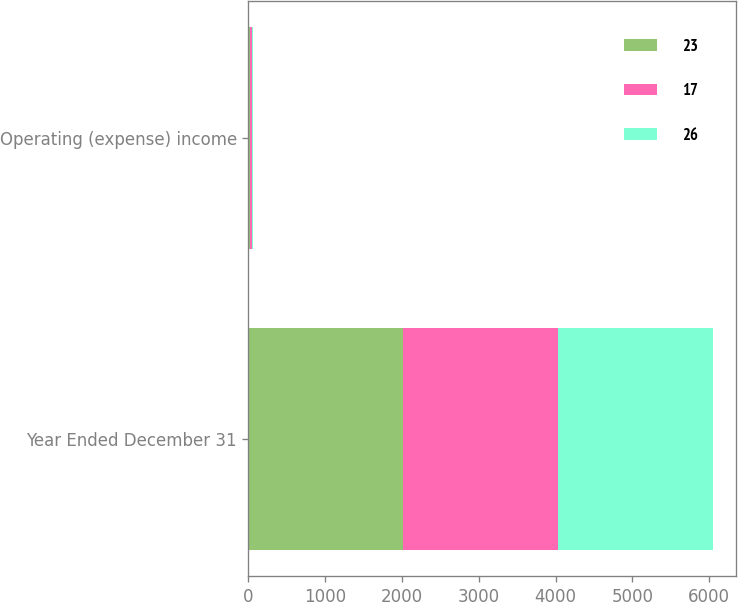<chart> <loc_0><loc_0><loc_500><loc_500><stacked_bar_chart><ecel><fcel>Year Ended December 31<fcel>Operating (expense) income<nl><fcel>23<fcel>2018<fcel>23<nl><fcel>17<fcel>2017<fcel>26<nl><fcel>26<fcel>2016<fcel>17<nl></chart> 